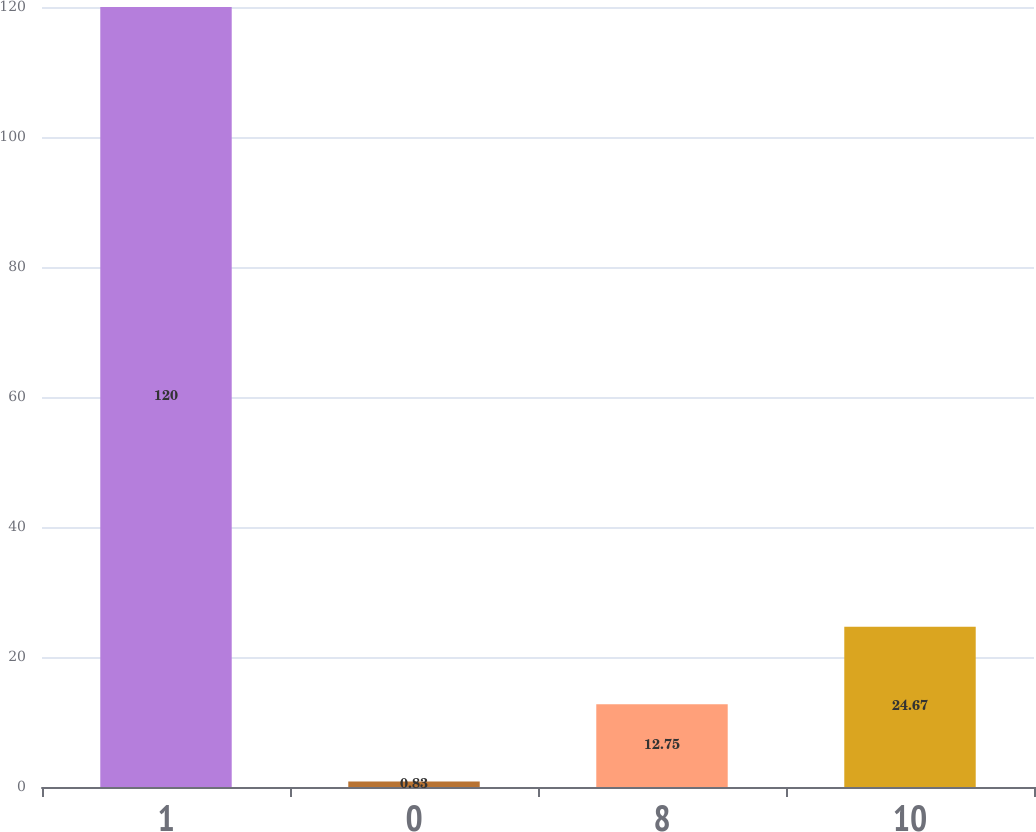Convert chart. <chart><loc_0><loc_0><loc_500><loc_500><bar_chart><fcel>1<fcel>0<fcel>8<fcel>10<nl><fcel>120<fcel>0.83<fcel>12.75<fcel>24.67<nl></chart> 